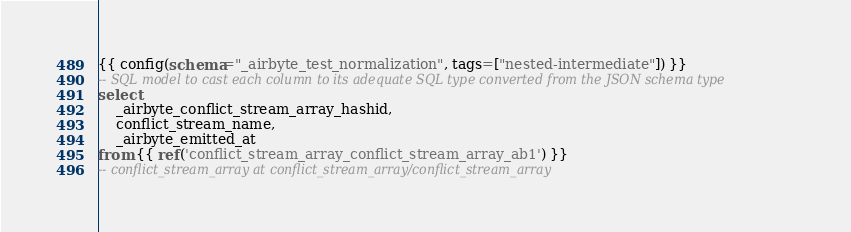Convert code to text. <code><loc_0><loc_0><loc_500><loc_500><_SQL_>{{ config(schema="_airbyte_test_normalization", tags=["nested-intermediate"]) }}
-- SQL model to cast each column to its adequate SQL type converted from the JSON schema type
select
    _airbyte_conflict_stream_array_hashid,
    conflict_stream_name,
    _airbyte_emitted_at
from {{ ref('conflict_stream_array_conflict_stream_array_ab1') }}
-- conflict_stream_array at conflict_stream_array/conflict_stream_array

</code> 